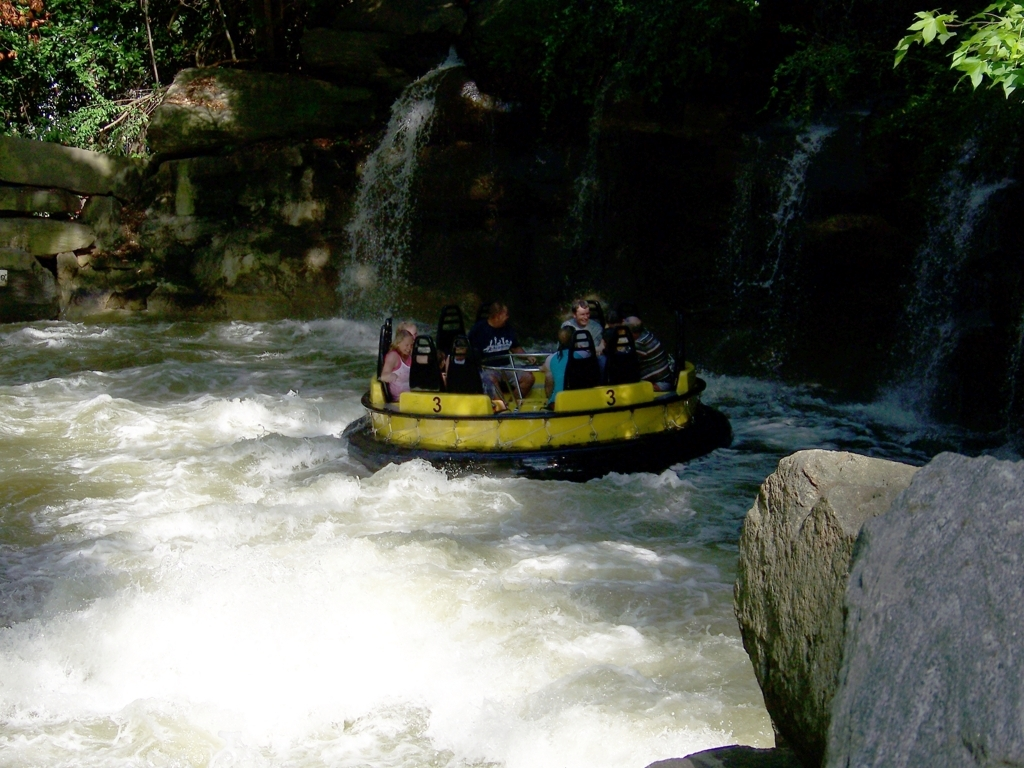Describe the environment in which this activity is taking place. The activity unfolds in a vibrant outdoor setting, with the raft coursing through what appears to be a man-made river channel. Waterfalls and lush vegetation envelop the sides, while the daylight pierces through the treetops, creating a dynamic and natural backdrop for this thrilling ride. 